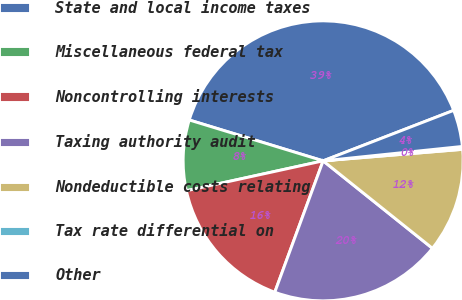<chart> <loc_0><loc_0><loc_500><loc_500><pie_chart><fcel>State and local income taxes<fcel>Miscellaneous federal tax<fcel>Noncontrolling interests<fcel>Taxing authority audit<fcel>Nondeductible costs relating<fcel>Tax rate differential on<fcel>Other<nl><fcel>39.41%<fcel>8.14%<fcel>15.96%<fcel>19.87%<fcel>12.05%<fcel>0.33%<fcel>4.23%<nl></chart> 